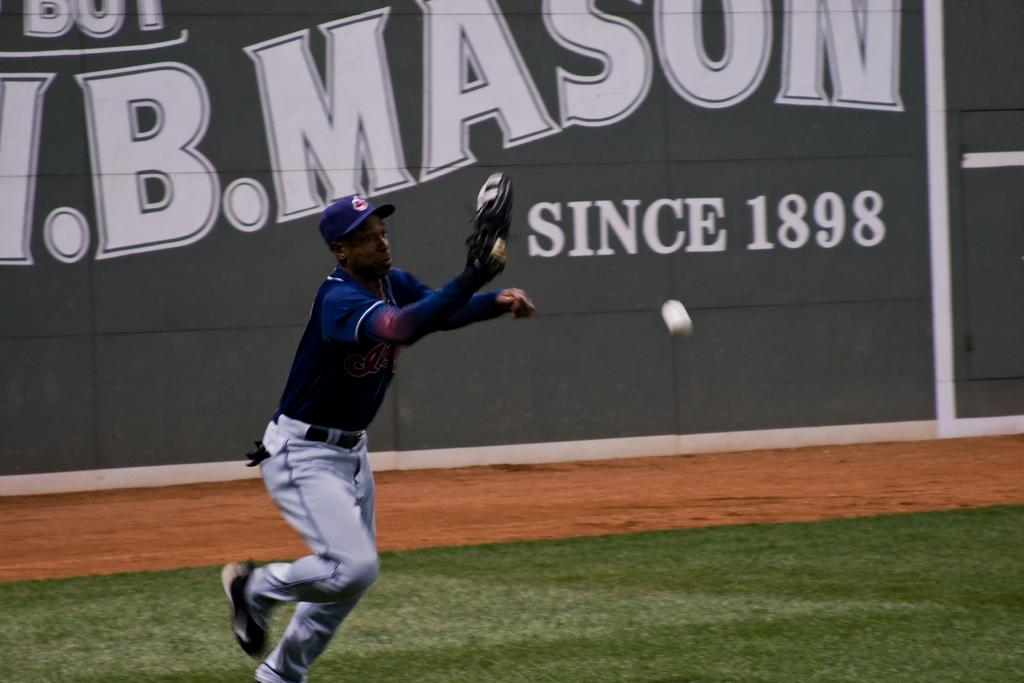<image>
Offer a succinct explanation of the picture presented. A baseball player is trying to catch the ball and the stadium wall says Mason Since 1898. 